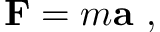Convert formula to latex. <formula><loc_0><loc_0><loc_500><loc_500>F = m a \ ,</formula> 